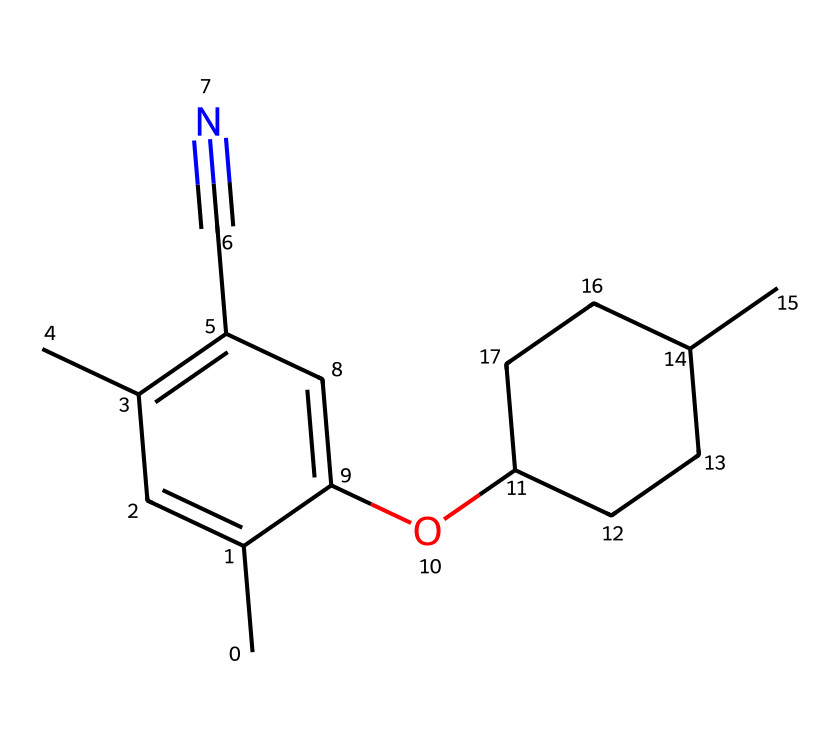What is the total number of carbon atoms in this compound? Count the number of carbon (C) symbols in the SMILES representation. There are 14 instances of 'C', which include both the carbon atoms in the rings and side chains.
Answer: fourteen How many ring structures are present in this molecule? Analyze the structure based on the SMILES; identify segments that indicate cyclic structures. There are two ring structures denoted by the 'C' characters forming closed loops in the middle of the molecule.
Answer: two Does this structure contain any heteroatoms? Look for letters in the SMILES that indicate elements other than carbon and hydrogen. The presence of 'O' indicates the existence of an oxygen atom, meaning it does contain a heteroatom.
Answer: yes What functional group can be inferred from the presence of the "-C#N" group in the structure? The "-C#N" notation indicates a cyano group, which is characterized by a carbon triple-bonded to a nitrogen atom. This suggests that the compound has a cyano functional group.
Answer: cyano Is there a double bond present within this molecule? Examine the structure for the presence of a double bond, which can be identified by the "=" symbol in the SMILES. The structure includes multiple instances of "=" in the carbon atoms, confirming the presence of double bonds.
Answer: yes What is the degree of unsaturation in this compound? Count the number of double bonds and rings to calculate total unsaturation. Each double bond contributes one degree of unsaturation, and each ring contributes one; thus, you tally the impacts from both to determine the overall degree. This compound exhibits multiple rings and double bonds, leading to a considerable degree of unsaturation.
Answer: six What is the significance of the "OC" fragment in the structure? The "OC" fragment indicates an ether functional group that includes an oxygen atom bonded to the carbon chain. This plays a crucial role in the compound's properties.
Answer: ether 